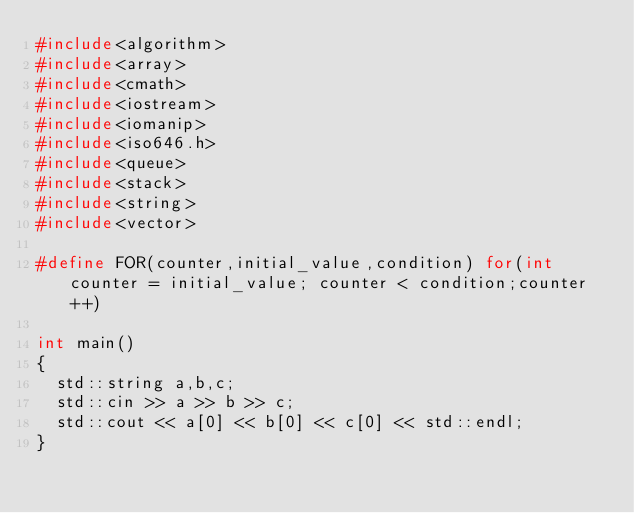Convert code to text. <code><loc_0><loc_0><loc_500><loc_500><_C++_>#include<algorithm>
#include<array>
#include<cmath>
#include<iostream>
#include<iomanip>
#include<iso646.h>
#include<queue>
#include<stack>
#include<string>
#include<vector>

#define FOR(counter,initial_value,condition) for(int counter = initial_value; counter < condition;counter++)

int main()
{
	std::string a,b,c;
	std::cin >> a >> b >> c;
	std::cout << a[0] << b[0] << c[0] << std::endl;
}</code> 